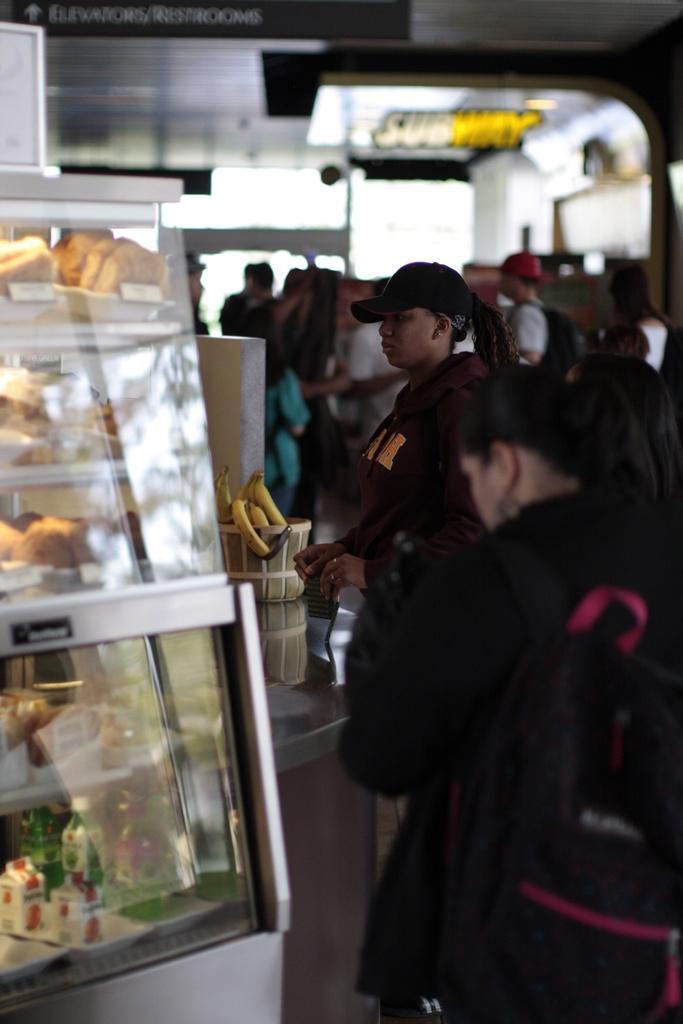In one or two sentences, can you explain what this image depicts? This image is taken in a subway. There are few people visible in this image. On the left there are food items like puff, soft drink bottles placed in a white glass container. There are also bananas visible in this image. At the top there is a text on the blackboard with direction. 